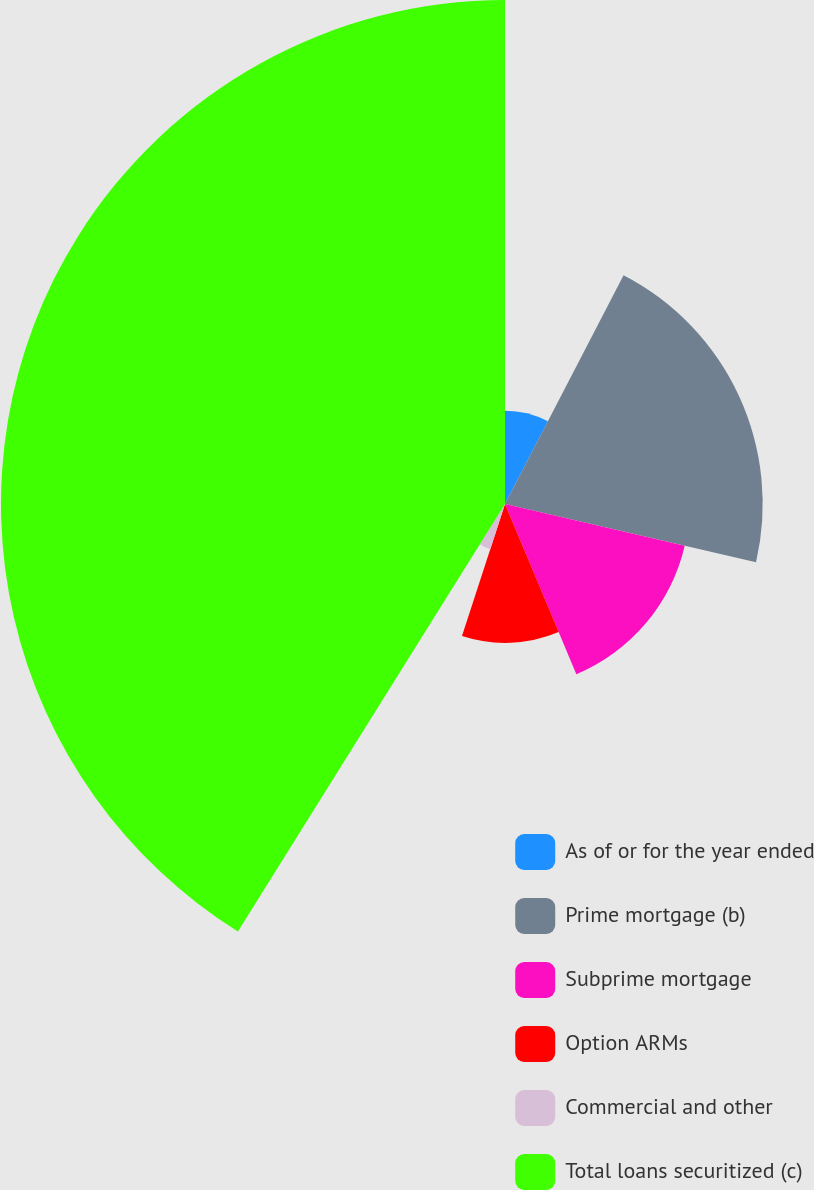Convert chart. <chart><loc_0><loc_0><loc_500><loc_500><pie_chart><fcel>As of or for the year ended<fcel>Prime mortgage (b)<fcel>Subprime mortgage<fcel>Option ARMs<fcel>Commercial and other<fcel>Total loans securitized (c)<nl><fcel>7.61%<fcel>21.02%<fcel>15.05%<fcel>11.33%<fcel>3.88%<fcel>41.11%<nl></chart> 